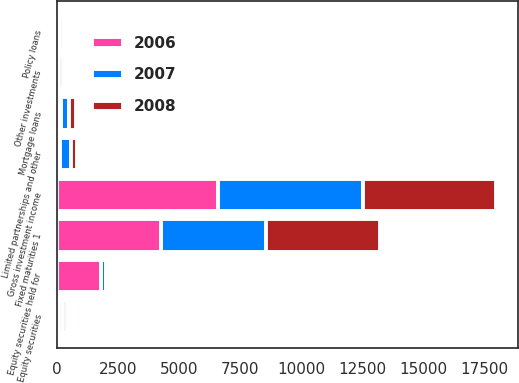Convert chart. <chart><loc_0><loc_0><loc_500><loc_500><stacked_bar_chart><ecel><fcel>Fixed maturities 1<fcel>Equity securities<fcel>Equity securities held for<fcel>Mortgage loans<fcel>Policy loans<fcel>Limited partnerships and other<fcel>Other investments<fcel>Gross investment income<nl><fcel>2007<fcel>4310<fcel>167<fcel>167<fcel>333<fcel>139<fcel>445<fcel>72<fcel>5908<nl><fcel>2008<fcel>4653<fcel>139<fcel>145<fcel>293<fcel>135<fcel>255<fcel>161<fcel>5459<nl><fcel>2006<fcel>4266<fcel>92<fcel>1824<fcel>158<fcel>142<fcel>133<fcel>13<fcel>6602<nl></chart> 